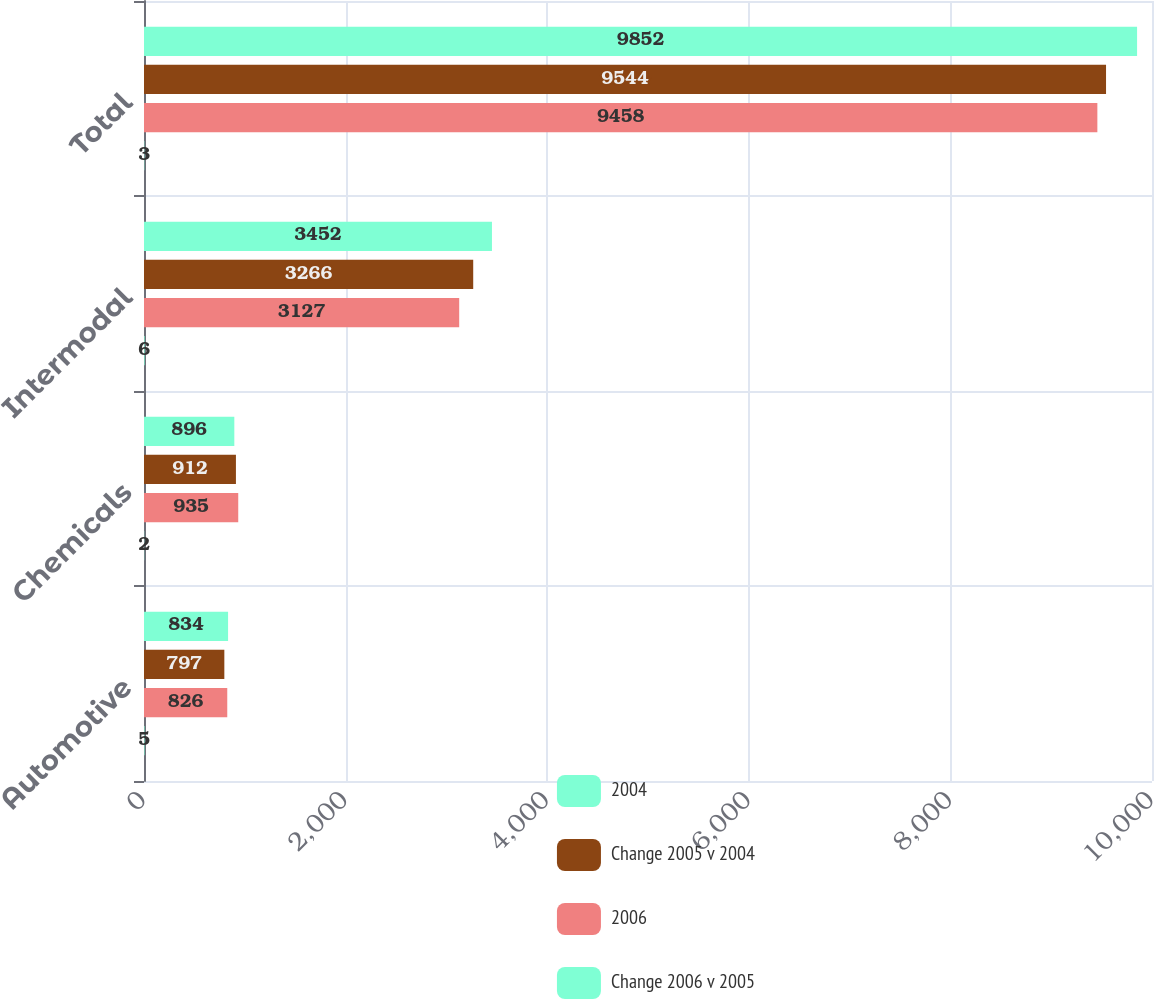Convert chart to OTSL. <chart><loc_0><loc_0><loc_500><loc_500><stacked_bar_chart><ecel><fcel>Automotive<fcel>Chemicals<fcel>Intermodal<fcel>Total<nl><fcel>2004<fcel>834<fcel>896<fcel>3452<fcel>9852<nl><fcel>Change 2005 v 2004<fcel>797<fcel>912<fcel>3266<fcel>9544<nl><fcel>2006<fcel>826<fcel>935<fcel>3127<fcel>9458<nl><fcel>Change 2006 v 2005<fcel>5<fcel>2<fcel>6<fcel>3<nl></chart> 